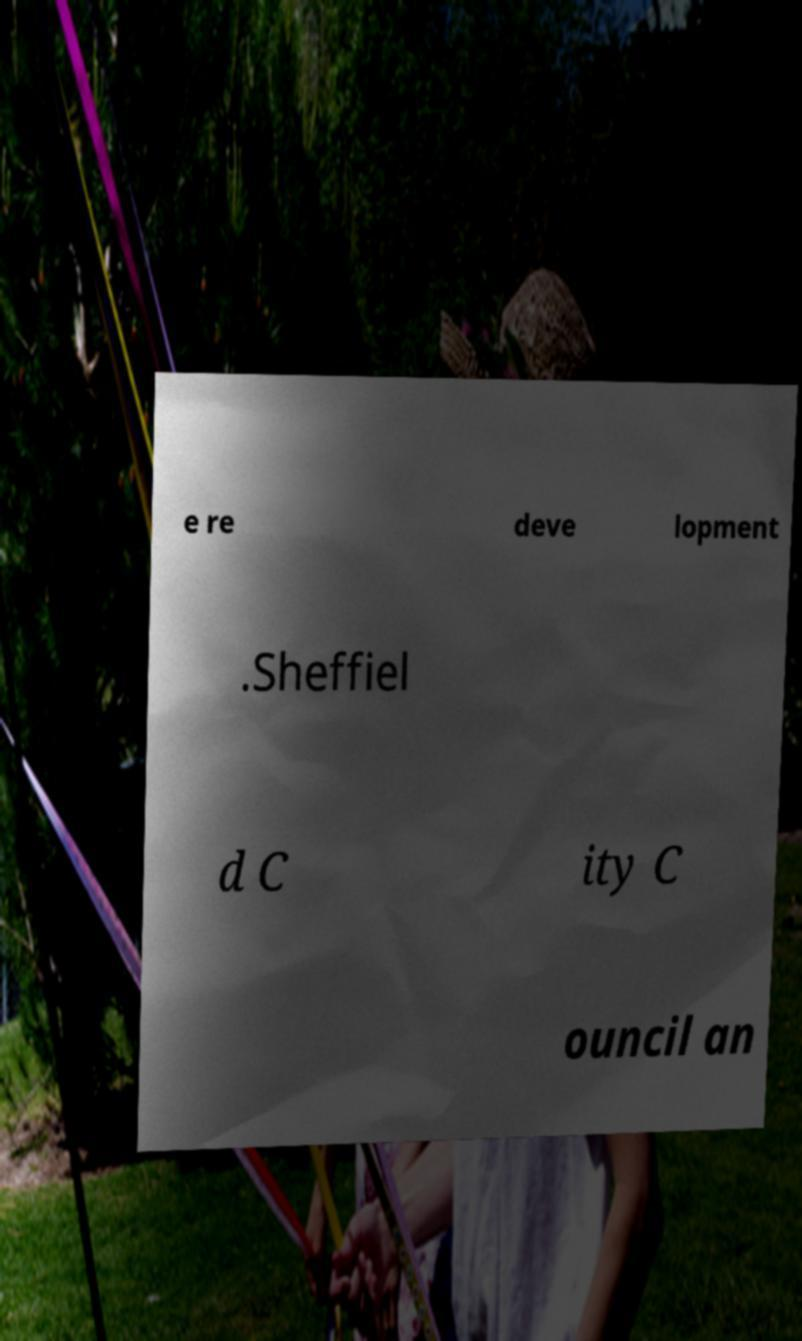Please identify and transcribe the text found in this image. e re deve lopment .Sheffiel d C ity C ouncil an 